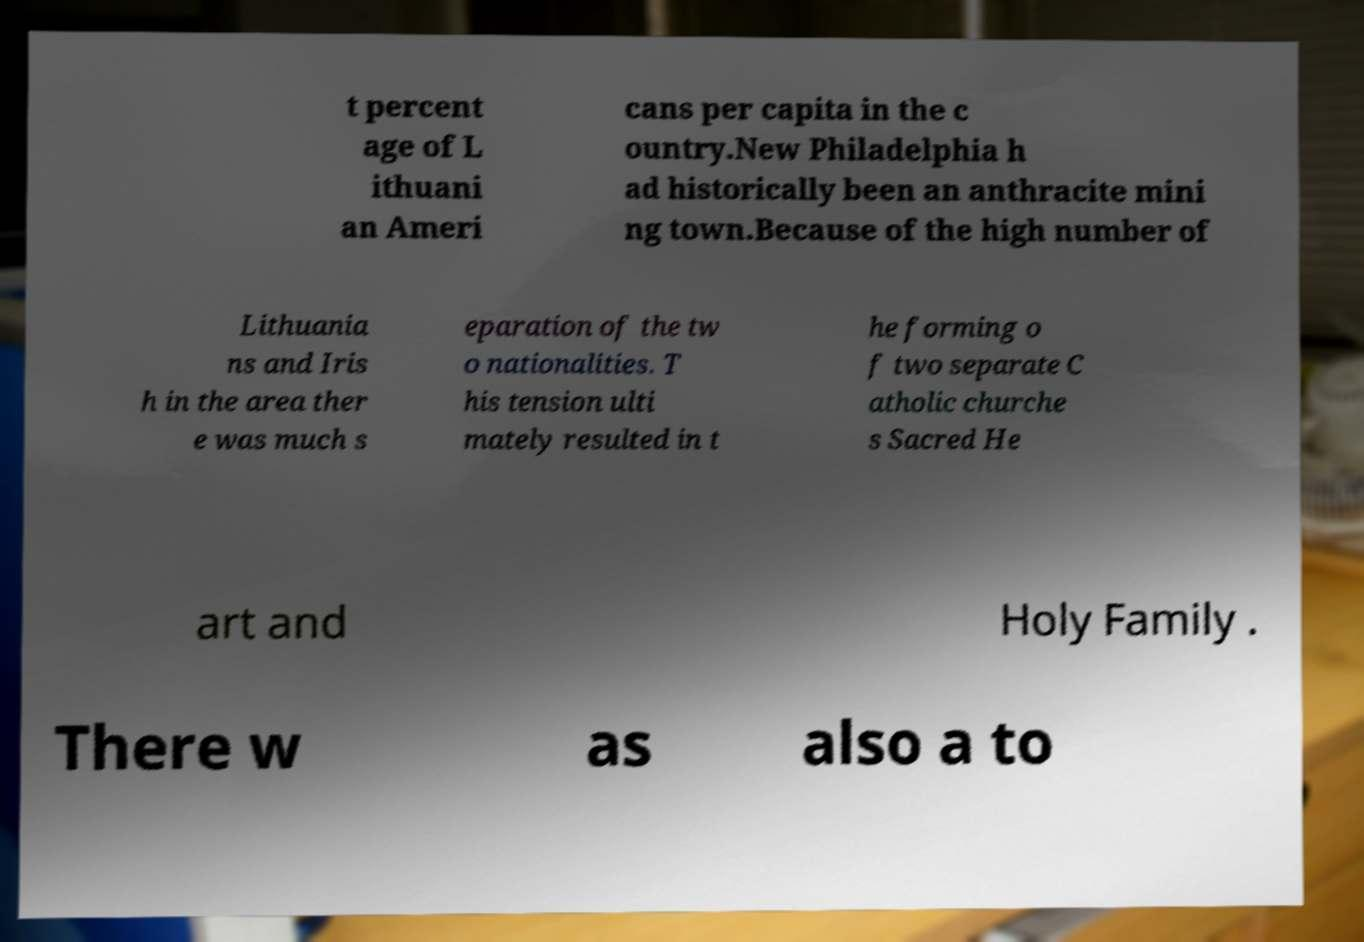I need the written content from this picture converted into text. Can you do that? t percent age of L ithuani an Ameri cans per capita in the c ountry.New Philadelphia h ad historically been an anthracite mini ng town.Because of the high number of Lithuania ns and Iris h in the area ther e was much s eparation of the tw o nationalities. T his tension ulti mately resulted in t he forming o f two separate C atholic churche s Sacred He art and Holy Family . There w as also a to 